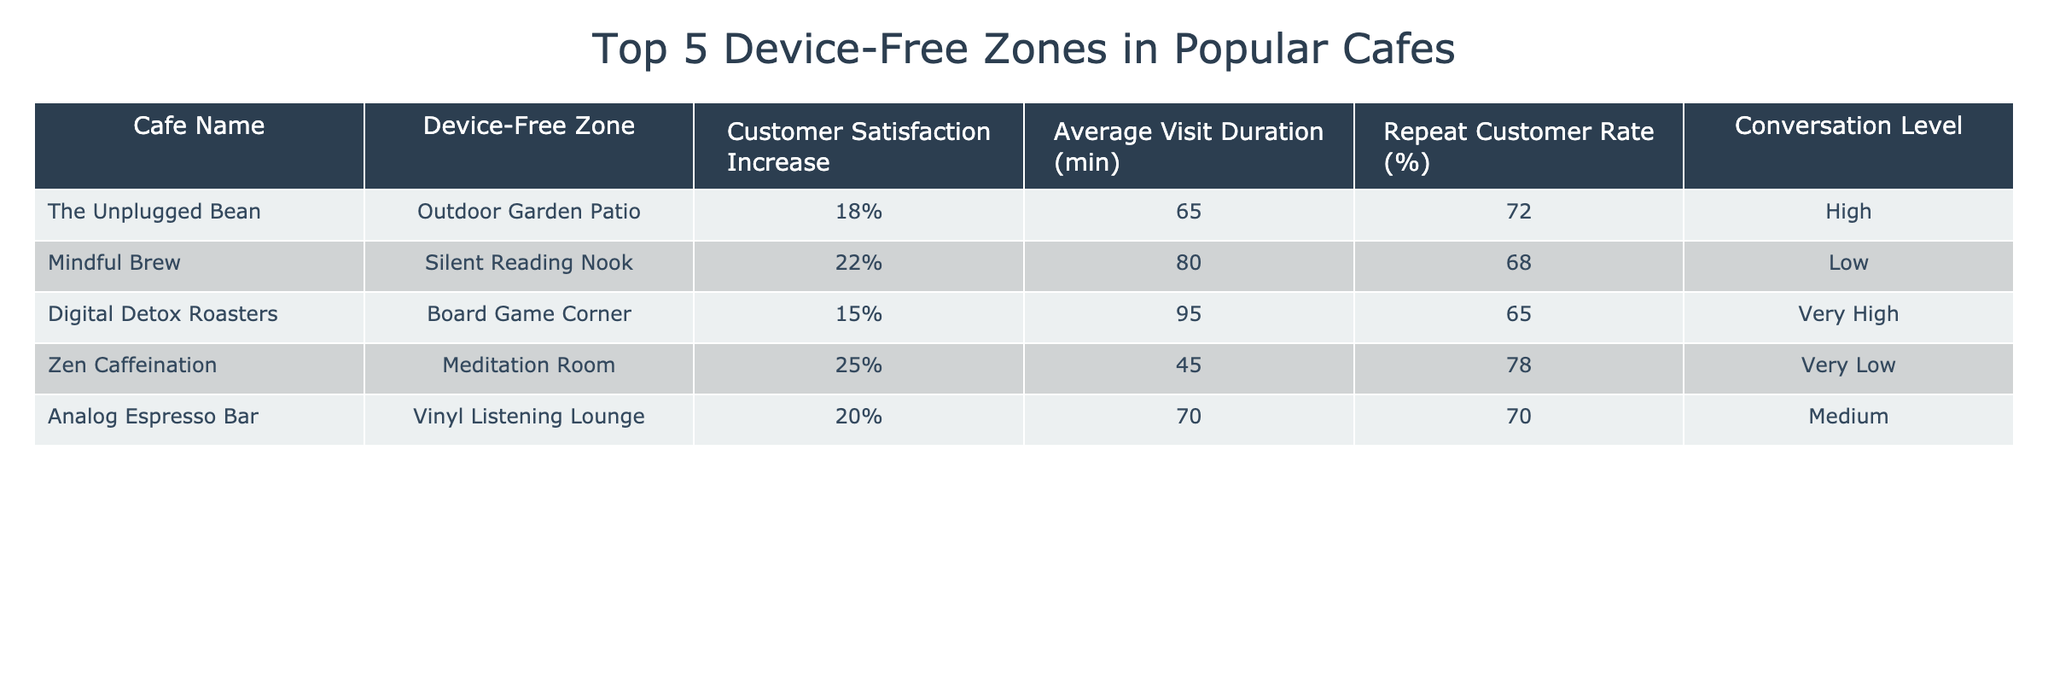What is the highest customer satisfaction increase among the cafes? The table lists the customer satisfaction increase percentages for each cafe. The highest percentage is 25% from Zen Caffeination.
Answer: 25% Which cafe has the lowest average visit duration? Looking at the average visit duration column, Zen Caffeination has the lowest duration of 45 minutes.
Answer: 45 minutes What is the repeat customer rate for Digital Detox Roasters? The table shows the repeat customer rate for Digital Detox Roasters as 65%.
Answer: 65% Is there a cafe with a very high conversation level that also has a customer satisfaction increase over 20%? By checking the conversation level and customer satisfaction increase, Digital Detox Roasters has a very high conversation level but only a 15% satisfaction increase. Therefore, no cafe meets both criteria.
Answer: No Which cafe has both the highest conversation level and the highest customer satisfaction increase? The highest customer satisfaction increase is 25% from Zen Caffeination, which has a very low conversation level. The cafe with the highest conversation level is Digital Detox Roasters with a customer satisfaction increase of 15%. Neither has both high metrics together.
Answer: No What is the average customer satisfaction increase across all cafes? The satisfaction increases are 18%, 22%, 15%, 25%, and 20%. Summing these gives 100%. Dividing by 5 gives an average of 20%.
Answer: 20% How many cafes have an average visit duration of 70 minutes or more? The cafes with 70 minutes or more in average visit duration are The Unplugged Bean (65 minutes), Mindful Brew (80 minutes), and Digital Detox Roasters (95 minutes). Therefore, two cafes meet this criterion.
Answer: 3 What is the difference in customer satisfaction increase between the highest and lowest values? The highest customer satisfaction increase is 25% (Zen Caffeination) and the lowest is 15% (Digital Detox Roasters). The difference is 25% - 15% = 10%.
Answer: 10% In terms of conversation level, which device-free zone has the highest percentage increase in customer satisfaction? Zen Caffeination's Meditation Room has the highest satisfaction increase at 25%, but has very low conversation levels.
Answer: Meditation Room Which cafe has the same average visit duration and repeat customer rate? By inspecting the table, Analog Espresso Bar has an average visit duration of 70 minutes and a repeat customer rate of 70%.
Answer: Analog Espresso Bar 